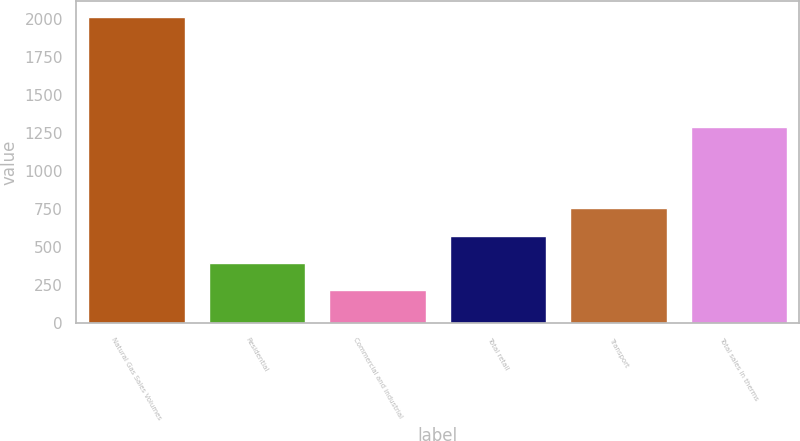<chart> <loc_0><loc_0><loc_500><loc_500><bar_chart><fcel>Natural Gas Sales Volumes<fcel>Residential<fcel>Commercial and industrial<fcel>Total retail<fcel>Transport<fcel>Total sales in therms<nl><fcel>2018<fcel>398.45<fcel>218.5<fcel>578.4<fcel>758.35<fcel>1293.3<nl></chart> 